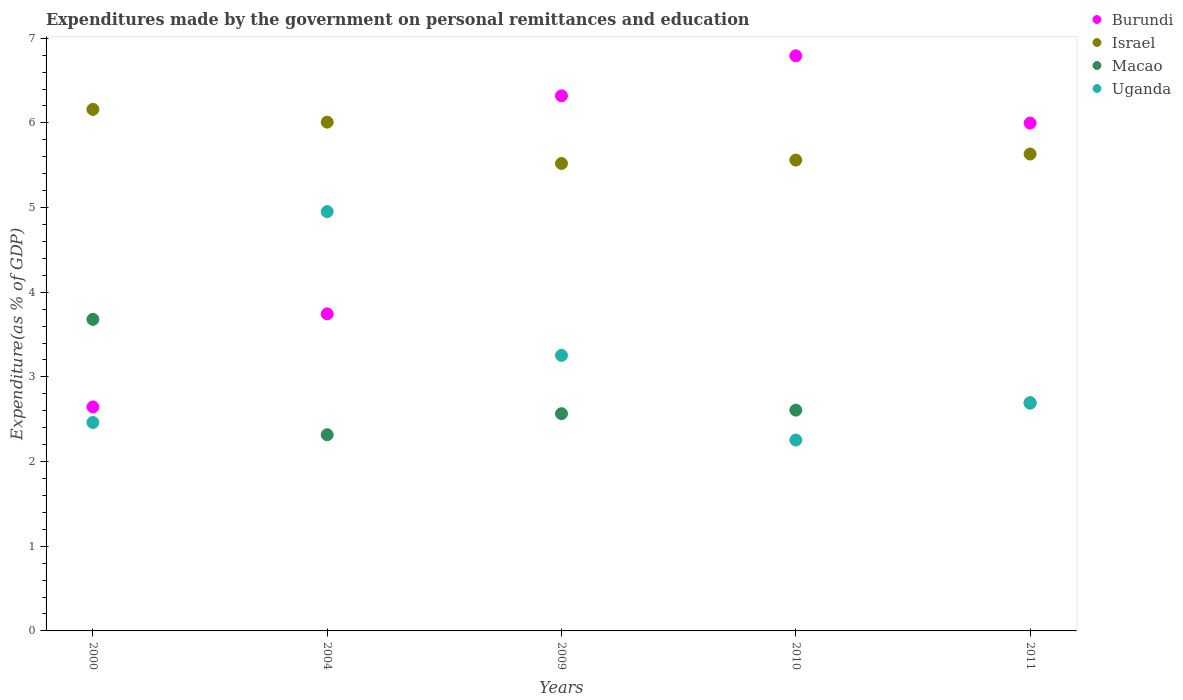How many different coloured dotlines are there?
Provide a succinct answer. 4. What is the expenditures made by the government on personal remittances and education in Macao in 2011?
Ensure brevity in your answer.  2.69. Across all years, what is the maximum expenditures made by the government on personal remittances and education in Israel?
Make the answer very short. 6.16. Across all years, what is the minimum expenditures made by the government on personal remittances and education in Israel?
Provide a succinct answer. 5.52. What is the total expenditures made by the government on personal remittances and education in Israel in the graph?
Give a very brief answer. 28.88. What is the difference between the expenditures made by the government on personal remittances and education in Macao in 2000 and that in 2009?
Give a very brief answer. 1.11. What is the difference between the expenditures made by the government on personal remittances and education in Israel in 2004 and the expenditures made by the government on personal remittances and education in Uganda in 2011?
Give a very brief answer. 3.31. What is the average expenditures made by the government on personal remittances and education in Israel per year?
Give a very brief answer. 5.78. In the year 2000, what is the difference between the expenditures made by the government on personal remittances and education in Macao and expenditures made by the government on personal remittances and education in Israel?
Keep it short and to the point. -2.48. In how many years, is the expenditures made by the government on personal remittances and education in Israel greater than 1.2 %?
Ensure brevity in your answer.  5. What is the ratio of the expenditures made by the government on personal remittances and education in Burundi in 2004 to that in 2010?
Offer a terse response. 0.55. Is the expenditures made by the government on personal remittances and education in Macao in 2004 less than that in 2009?
Make the answer very short. Yes. Is the difference between the expenditures made by the government on personal remittances and education in Macao in 2004 and 2009 greater than the difference between the expenditures made by the government on personal remittances and education in Israel in 2004 and 2009?
Provide a short and direct response. No. What is the difference between the highest and the second highest expenditures made by the government on personal remittances and education in Burundi?
Your answer should be compact. 0.47. What is the difference between the highest and the lowest expenditures made by the government on personal remittances and education in Macao?
Give a very brief answer. 1.36. In how many years, is the expenditures made by the government on personal remittances and education in Uganda greater than the average expenditures made by the government on personal remittances and education in Uganda taken over all years?
Offer a terse response. 2. Is it the case that in every year, the sum of the expenditures made by the government on personal remittances and education in Macao and expenditures made by the government on personal remittances and education in Uganda  is greater than the sum of expenditures made by the government on personal remittances and education in Israel and expenditures made by the government on personal remittances and education in Burundi?
Keep it short and to the point. No. Is the expenditures made by the government on personal remittances and education in Macao strictly greater than the expenditures made by the government on personal remittances and education in Israel over the years?
Offer a very short reply. No. How many dotlines are there?
Your answer should be compact. 4. How many years are there in the graph?
Ensure brevity in your answer.  5. What is the difference between two consecutive major ticks on the Y-axis?
Offer a terse response. 1. Does the graph contain grids?
Offer a terse response. No. Where does the legend appear in the graph?
Offer a very short reply. Top right. How are the legend labels stacked?
Keep it short and to the point. Vertical. What is the title of the graph?
Give a very brief answer. Expenditures made by the government on personal remittances and education. What is the label or title of the X-axis?
Give a very brief answer. Years. What is the label or title of the Y-axis?
Offer a very short reply. Expenditure(as % of GDP). What is the Expenditure(as % of GDP) in Burundi in 2000?
Your answer should be very brief. 2.65. What is the Expenditure(as % of GDP) in Israel in 2000?
Give a very brief answer. 6.16. What is the Expenditure(as % of GDP) of Macao in 2000?
Provide a succinct answer. 3.68. What is the Expenditure(as % of GDP) in Uganda in 2000?
Give a very brief answer. 2.46. What is the Expenditure(as % of GDP) in Burundi in 2004?
Ensure brevity in your answer.  3.74. What is the Expenditure(as % of GDP) of Israel in 2004?
Your answer should be compact. 6.01. What is the Expenditure(as % of GDP) of Macao in 2004?
Make the answer very short. 2.32. What is the Expenditure(as % of GDP) of Uganda in 2004?
Ensure brevity in your answer.  4.95. What is the Expenditure(as % of GDP) in Burundi in 2009?
Provide a short and direct response. 6.32. What is the Expenditure(as % of GDP) in Israel in 2009?
Give a very brief answer. 5.52. What is the Expenditure(as % of GDP) of Macao in 2009?
Provide a short and direct response. 2.57. What is the Expenditure(as % of GDP) in Uganda in 2009?
Ensure brevity in your answer.  3.25. What is the Expenditure(as % of GDP) in Burundi in 2010?
Offer a terse response. 6.79. What is the Expenditure(as % of GDP) of Israel in 2010?
Offer a terse response. 5.56. What is the Expenditure(as % of GDP) in Macao in 2010?
Make the answer very short. 2.61. What is the Expenditure(as % of GDP) of Uganda in 2010?
Offer a very short reply. 2.25. What is the Expenditure(as % of GDP) in Burundi in 2011?
Provide a short and direct response. 6. What is the Expenditure(as % of GDP) in Israel in 2011?
Your response must be concise. 5.63. What is the Expenditure(as % of GDP) in Macao in 2011?
Your response must be concise. 2.69. What is the Expenditure(as % of GDP) of Uganda in 2011?
Keep it short and to the point. 2.7. Across all years, what is the maximum Expenditure(as % of GDP) of Burundi?
Ensure brevity in your answer.  6.79. Across all years, what is the maximum Expenditure(as % of GDP) of Israel?
Your answer should be compact. 6.16. Across all years, what is the maximum Expenditure(as % of GDP) of Macao?
Your response must be concise. 3.68. Across all years, what is the maximum Expenditure(as % of GDP) in Uganda?
Provide a short and direct response. 4.95. Across all years, what is the minimum Expenditure(as % of GDP) of Burundi?
Make the answer very short. 2.65. Across all years, what is the minimum Expenditure(as % of GDP) in Israel?
Offer a very short reply. 5.52. Across all years, what is the minimum Expenditure(as % of GDP) of Macao?
Provide a succinct answer. 2.32. Across all years, what is the minimum Expenditure(as % of GDP) in Uganda?
Offer a terse response. 2.25. What is the total Expenditure(as % of GDP) in Burundi in the graph?
Your answer should be compact. 25.5. What is the total Expenditure(as % of GDP) of Israel in the graph?
Your answer should be very brief. 28.88. What is the total Expenditure(as % of GDP) of Macao in the graph?
Ensure brevity in your answer.  13.86. What is the total Expenditure(as % of GDP) in Uganda in the graph?
Ensure brevity in your answer.  15.62. What is the difference between the Expenditure(as % of GDP) in Burundi in 2000 and that in 2004?
Your answer should be very brief. -1.1. What is the difference between the Expenditure(as % of GDP) of Israel in 2000 and that in 2004?
Offer a terse response. 0.15. What is the difference between the Expenditure(as % of GDP) of Macao in 2000 and that in 2004?
Offer a very short reply. 1.36. What is the difference between the Expenditure(as % of GDP) in Uganda in 2000 and that in 2004?
Make the answer very short. -2.49. What is the difference between the Expenditure(as % of GDP) of Burundi in 2000 and that in 2009?
Provide a short and direct response. -3.67. What is the difference between the Expenditure(as % of GDP) of Israel in 2000 and that in 2009?
Provide a succinct answer. 0.64. What is the difference between the Expenditure(as % of GDP) in Macao in 2000 and that in 2009?
Keep it short and to the point. 1.11. What is the difference between the Expenditure(as % of GDP) of Uganda in 2000 and that in 2009?
Give a very brief answer. -0.79. What is the difference between the Expenditure(as % of GDP) in Burundi in 2000 and that in 2010?
Your response must be concise. -4.15. What is the difference between the Expenditure(as % of GDP) in Israel in 2000 and that in 2010?
Offer a very short reply. 0.6. What is the difference between the Expenditure(as % of GDP) of Macao in 2000 and that in 2010?
Ensure brevity in your answer.  1.07. What is the difference between the Expenditure(as % of GDP) in Uganda in 2000 and that in 2010?
Ensure brevity in your answer.  0.21. What is the difference between the Expenditure(as % of GDP) of Burundi in 2000 and that in 2011?
Offer a terse response. -3.35. What is the difference between the Expenditure(as % of GDP) in Israel in 2000 and that in 2011?
Provide a succinct answer. 0.53. What is the difference between the Expenditure(as % of GDP) in Macao in 2000 and that in 2011?
Make the answer very short. 0.99. What is the difference between the Expenditure(as % of GDP) in Uganda in 2000 and that in 2011?
Give a very brief answer. -0.23. What is the difference between the Expenditure(as % of GDP) of Burundi in 2004 and that in 2009?
Provide a succinct answer. -2.57. What is the difference between the Expenditure(as % of GDP) in Israel in 2004 and that in 2009?
Your response must be concise. 0.49. What is the difference between the Expenditure(as % of GDP) of Macao in 2004 and that in 2009?
Keep it short and to the point. -0.25. What is the difference between the Expenditure(as % of GDP) of Uganda in 2004 and that in 2009?
Your answer should be very brief. 1.7. What is the difference between the Expenditure(as % of GDP) of Burundi in 2004 and that in 2010?
Ensure brevity in your answer.  -3.05. What is the difference between the Expenditure(as % of GDP) in Israel in 2004 and that in 2010?
Give a very brief answer. 0.45. What is the difference between the Expenditure(as % of GDP) in Macao in 2004 and that in 2010?
Your answer should be very brief. -0.29. What is the difference between the Expenditure(as % of GDP) in Uganda in 2004 and that in 2010?
Offer a very short reply. 2.7. What is the difference between the Expenditure(as % of GDP) of Burundi in 2004 and that in 2011?
Your answer should be compact. -2.25. What is the difference between the Expenditure(as % of GDP) in Israel in 2004 and that in 2011?
Make the answer very short. 0.38. What is the difference between the Expenditure(as % of GDP) in Macao in 2004 and that in 2011?
Provide a succinct answer. -0.37. What is the difference between the Expenditure(as % of GDP) of Uganda in 2004 and that in 2011?
Offer a terse response. 2.26. What is the difference between the Expenditure(as % of GDP) in Burundi in 2009 and that in 2010?
Provide a short and direct response. -0.47. What is the difference between the Expenditure(as % of GDP) of Israel in 2009 and that in 2010?
Your response must be concise. -0.04. What is the difference between the Expenditure(as % of GDP) in Macao in 2009 and that in 2010?
Give a very brief answer. -0.04. What is the difference between the Expenditure(as % of GDP) in Burundi in 2009 and that in 2011?
Make the answer very short. 0.32. What is the difference between the Expenditure(as % of GDP) of Israel in 2009 and that in 2011?
Ensure brevity in your answer.  -0.11. What is the difference between the Expenditure(as % of GDP) of Macao in 2009 and that in 2011?
Your response must be concise. -0.12. What is the difference between the Expenditure(as % of GDP) in Uganda in 2009 and that in 2011?
Offer a terse response. 0.56. What is the difference between the Expenditure(as % of GDP) in Burundi in 2010 and that in 2011?
Your response must be concise. 0.8. What is the difference between the Expenditure(as % of GDP) in Israel in 2010 and that in 2011?
Ensure brevity in your answer.  -0.07. What is the difference between the Expenditure(as % of GDP) of Macao in 2010 and that in 2011?
Your answer should be very brief. -0.08. What is the difference between the Expenditure(as % of GDP) of Uganda in 2010 and that in 2011?
Ensure brevity in your answer.  -0.44. What is the difference between the Expenditure(as % of GDP) of Burundi in 2000 and the Expenditure(as % of GDP) of Israel in 2004?
Make the answer very short. -3.36. What is the difference between the Expenditure(as % of GDP) in Burundi in 2000 and the Expenditure(as % of GDP) in Macao in 2004?
Offer a very short reply. 0.33. What is the difference between the Expenditure(as % of GDP) of Burundi in 2000 and the Expenditure(as % of GDP) of Uganda in 2004?
Offer a very short reply. -2.31. What is the difference between the Expenditure(as % of GDP) of Israel in 2000 and the Expenditure(as % of GDP) of Macao in 2004?
Your response must be concise. 3.84. What is the difference between the Expenditure(as % of GDP) in Israel in 2000 and the Expenditure(as % of GDP) in Uganda in 2004?
Provide a short and direct response. 1.21. What is the difference between the Expenditure(as % of GDP) of Macao in 2000 and the Expenditure(as % of GDP) of Uganda in 2004?
Give a very brief answer. -1.27. What is the difference between the Expenditure(as % of GDP) in Burundi in 2000 and the Expenditure(as % of GDP) in Israel in 2009?
Offer a very short reply. -2.88. What is the difference between the Expenditure(as % of GDP) in Burundi in 2000 and the Expenditure(as % of GDP) in Macao in 2009?
Offer a very short reply. 0.08. What is the difference between the Expenditure(as % of GDP) of Burundi in 2000 and the Expenditure(as % of GDP) of Uganda in 2009?
Your answer should be very brief. -0.61. What is the difference between the Expenditure(as % of GDP) in Israel in 2000 and the Expenditure(as % of GDP) in Macao in 2009?
Ensure brevity in your answer.  3.59. What is the difference between the Expenditure(as % of GDP) of Israel in 2000 and the Expenditure(as % of GDP) of Uganda in 2009?
Your answer should be compact. 2.91. What is the difference between the Expenditure(as % of GDP) of Macao in 2000 and the Expenditure(as % of GDP) of Uganda in 2009?
Your response must be concise. 0.43. What is the difference between the Expenditure(as % of GDP) in Burundi in 2000 and the Expenditure(as % of GDP) in Israel in 2010?
Provide a succinct answer. -2.92. What is the difference between the Expenditure(as % of GDP) in Burundi in 2000 and the Expenditure(as % of GDP) in Macao in 2010?
Ensure brevity in your answer.  0.04. What is the difference between the Expenditure(as % of GDP) in Burundi in 2000 and the Expenditure(as % of GDP) in Uganda in 2010?
Provide a succinct answer. 0.39. What is the difference between the Expenditure(as % of GDP) of Israel in 2000 and the Expenditure(as % of GDP) of Macao in 2010?
Give a very brief answer. 3.55. What is the difference between the Expenditure(as % of GDP) of Israel in 2000 and the Expenditure(as % of GDP) of Uganda in 2010?
Provide a short and direct response. 3.91. What is the difference between the Expenditure(as % of GDP) in Macao in 2000 and the Expenditure(as % of GDP) in Uganda in 2010?
Give a very brief answer. 1.43. What is the difference between the Expenditure(as % of GDP) in Burundi in 2000 and the Expenditure(as % of GDP) in Israel in 2011?
Your response must be concise. -2.99. What is the difference between the Expenditure(as % of GDP) of Burundi in 2000 and the Expenditure(as % of GDP) of Macao in 2011?
Provide a succinct answer. -0.05. What is the difference between the Expenditure(as % of GDP) of Burundi in 2000 and the Expenditure(as % of GDP) of Uganda in 2011?
Your response must be concise. -0.05. What is the difference between the Expenditure(as % of GDP) of Israel in 2000 and the Expenditure(as % of GDP) of Macao in 2011?
Make the answer very short. 3.47. What is the difference between the Expenditure(as % of GDP) of Israel in 2000 and the Expenditure(as % of GDP) of Uganda in 2011?
Make the answer very short. 3.46. What is the difference between the Expenditure(as % of GDP) in Macao in 2000 and the Expenditure(as % of GDP) in Uganda in 2011?
Your answer should be compact. 0.98. What is the difference between the Expenditure(as % of GDP) in Burundi in 2004 and the Expenditure(as % of GDP) in Israel in 2009?
Your answer should be very brief. -1.78. What is the difference between the Expenditure(as % of GDP) in Burundi in 2004 and the Expenditure(as % of GDP) in Macao in 2009?
Your answer should be very brief. 1.18. What is the difference between the Expenditure(as % of GDP) of Burundi in 2004 and the Expenditure(as % of GDP) of Uganda in 2009?
Give a very brief answer. 0.49. What is the difference between the Expenditure(as % of GDP) of Israel in 2004 and the Expenditure(as % of GDP) of Macao in 2009?
Your answer should be very brief. 3.44. What is the difference between the Expenditure(as % of GDP) in Israel in 2004 and the Expenditure(as % of GDP) in Uganda in 2009?
Keep it short and to the point. 2.75. What is the difference between the Expenditure(as % of GDP) of Macao in 2004 and the Expenditure(as % of GDP) of Uganda in 2009?
Your response must be concise. -0.94. What is the difference between the Expenditure(as % of GDP) in Burundi in 2004 and the Expenditure(as % of GDP) in Israel in 2010?
Ensure brevity in your answer.  -1.82. What is the difference between the Expenditure(as % of GDP) in Burundi in 2004 and the Expenditure(as % of GDP) in Macao in 2010?
Provide a short and direct response. 1.14. What is the difference between the Expenditure(as % of GDP) of Burundi in 2004 and the Expenditure(as % of GDP) of Uganda in 2010?
Provide a succinct answer. 1.49. What is the difference between the Expenditure(as % of GDP) in Israel in 2004 and the Expenditure(as % of GDP) in Macao in 2010?
Ensure brevity in your answer.  3.4. What is the difference between the Expenditure(as % of GDP) in Israel in 2004 and the Expenditure(as % of GDP) in Uganda in 2010?
Your response must be concise. 3.75. What is the difference between the Expenditure(as % of GDP) in Macao in 2004 and the Expenditure(as % of GDP) in Uganda in 2010?
Make the answer very short. 0.06. What is the difference between the Expenditure(as % of GDP) of Burundi in 2004 and the Expenditure(as % of GDP) of Israel in 2011?
Provide a short and direct response. -1.89. What is the difference between the Expenditure(as % of GDP) in Burundi in 2004 and the Expenditure(as % of GDP) in Macao in 2011?
Provide a succinct answer. 1.05. What is the difference between the Expenditure(as % of GDP) in Burundi in 2004 and the Expenditure(as % of GDP) in Uganda in 2011?
Make the answer very short. 1.05. What is the difference between the Expenditure(as % of GDP) in Israel in 2004 and the Expenditure(as % of GDP) in Macao in 2011?
Your answer should be very brief. 3.32. What is the difference between the Expenditure(as % of GDP) in Israel in 2004 and the Expenditure(as % of GDP) in Uganda in 2011?
Make the answer very short. 3.31. What is the difference between the Expenditure(as % of GDP) of Macao in 2004 and the Expenditure(as % of GDP) of Uganda in 2011?
Your answer should be very brief. -0.38. What is the difference between the Expenditure(as % of GDP) of Burundi in 2009 and the Expenditure(as % of GDP) of Israel in 2010?
Your answer should be compact. 0.76. What is the difference between the Expenditure(as % of GDP) in Burundi in 2009 and the Expenditure(as % of GDP) in Macao in 2010?
Make the answer very short. 3.71. What is the difference between the Expenditure(as % of GDP) in Burundi in 2009 and the Expenditure(as % of GDP) in Uganda in 2010?
Make the answer very short. 4.07. What is the difference between the Expenditure(as % of GDP) in Israel in 2009 and the Expenditure(as % of GDP) in Macao in 2010?
Provide a succinct answer. 2.91. What is the difference between the Expenditure(as % of GDP) in Israel in 2009 and the Expenditure(as % of GDP) in Uganda in 2010?
Keep it short and to the point. 3.27. What is the difference between the Expenditure(as % of GDP) in Macao in 2009 and the Expenditure(as % of GDP) in Uganda in 2010?
Ensure brevity in your answer.  0.31. What is the difference between the Expenditure(as % of GDP) of Burundi in 2009 and the Expenditure(as % of GDP) of Israel in 2011?
Your response must be concise. 0.69. What is the difference between the Expenditure(as % of GDP) in Burundi in 2009 and the Expenditure(as % of GDP) in Macao in 2011?
Offer a terse response. 3.63. What is the difference between the Expenditure(as % of GDP) in Burundi in 2009 and the Expenditure(as % of GDP) in Uganda in 2011?
Offer a terse response. 3.62. What is the difference between the Expenditure(as % of GDP) in Israel in 2009 and the Expenditure(as % of GDP) in Macao in 2011?
Your response must be concise. 2.83. What is the difference between the Expenditure(as % of GDP) of Israel in 2009 and the Expenditure(as % of GDP) of Uganda in 2011?
Your response must be concise. 2.83. What is the difference between the Expenditure(as % of GDP) in Macao in 2009 and the Expenditure(as % of GDP) in Uganda in 2011?
Provide a succinct answer. -0.13. What is the difference between the Expenditure(as % of GDP) in Burundi in 2010 and the Expenditure(as % of GDP) in Israel in 2011?
Your response must be concise. 1.16. What is the difference between the Expenditure(as % of GDP) in Burundi in 2010 and the Expenditure(as % of GDP) in Macao in 2011?
Your response must be concise. 4.1. What is the difference between the Expenditure(as % of GDP) in Burundi in 2010 and the Expenditure(as % of GDP) in Uganda in 2011?
Your answer should be compact. 4.1. What is the difference between the Expenditure(as % of GDP) of Israel in 2010 and the Expenditure(as % of GDP) of Macao in 2011?
Your response must be concise. 2.87. What is the difference between the Expenditure(as % of GDP) of Israel in 2010 and the Expenditure(as % of GDP) of Uganda in 2011?
Offer a terse response. 2.87. What is the difference between the Expenditure(as % of GDP) of Macao in 2010 and the Expenditure(as % of GDP) of Uganda in 2011?
Your answer should be compact. -0.09. What is the average Expenditure(as % of GDP) of Burundi per year?
Offer a terse response. 5.1. What is the average Expenditure(as % of GDP) of Israel per year?
Offer a very short reply. 5.78. What is the average Expenditure(as % of GDP) of Macao per year?
Offer a terse response. 2.77. What is the average Expenditure(as % of GDP) of Uganda per year?
Your answer should be very brief. 3.12. In the year 2000, what is the difference between the Expenditure(as % of GDP) of Burundi and Expenditure(as % of GDP) of Israel?
Your response must be concise. -3.51. In the year 2000, what is the difference between the Expenditure(as % of GDP) in Burundi and Expenditure(as % of GDP) in Macao?
Offer a very short reply. -1.03. In the year 2000, what is the difference between the Expenditure(as % of GDP) in Burundi and Expenditure(as % of GDP) in Uganda?
Keep it short and to the point. 0.18. In the year 2000, what is the difference between the Expenditure(as % of GDP) of Israel and Expenditure(as % of GDP) of Macao?
Provide a short and direct response. 2.48. In the year 2000, what is the difference between the Expenditure(as % of GDP) of Israel and Expenditure(as % of GDP) of Uganda?
Offer a terse response. 3.7. In the year 2000, what is the difference between the Expenditure(as % of GDP) of Macao and Expenditure(as % of GDP) of Uganda?
Make the answer very short. 1.22. In the year 2004, what is the difference between the Expenditure(as % of GDP) in Burundi and Expenditure(as % of GDP) in Israel?
Your answer should be very brief. -2.26. In the year 2004, what is the difference between the Expenditure(as % of GDP) in Burundi and Expenditure(as % of GDP) in Macao?
Your answer should be compact. 1.43. In the year 2004, what is the difference between the Expenditure(as % of GDP) in Burundi and Expenditure(as % of GDP) in Uganda?
Provide a succinct answer. -1.21. In the year 2004, what is the difference between the Expenditure(as % of GDP) of Israel and Expenditure(as % of GDP) of Macao?
Ensure brevity in your answer.  3.69. In the year 2004, what is the difference between the Expenditure(as % of GDP) in Israel and Expenditure(as % of GDP) in Uganda?
Offer a very short reply. 1.06. In the year 2004, what is the difference between the Expenditure(as % of GDP) in Macao and Expenditure(as % of GDP) in Uganda?
Keep it short and to the point. -2.64. In the year 2009, what is the difference between the Expenditure(as % of GDP) of Burundi and Expenditure(as % of GDP) of Israel?
Keep it short and to the point. 0.8. In the year 2009, what is the difference between the Expenditure(as % of GDP) in Burundi and Expenditure(as % of GDP) in Macao?
Provide a succinct answer. 3.75. In the year 2009, what is the difference between the Expenditure(as % of GDP) in Burundi and Expenditure(as % of GDP) in Uganda?
Your response must be concise. 3.07. In the year 2009, what is the difference between the Expenditure(as % of GDP) in Israel and Expenditure(as % of GDP) in Macao?
Offer a terse response. 2.96. In the year 2009, what is the difference between the Expenditure(as % of GDP) of Israel and Expenditure(as % of GDP) of Uganda?
Keep it short and to the point. 2.27. In the year 2009, what is the difference between the Expenditure(as % of GDP) in Macao and Expenditure(as % of GDP) in Uganda?
Ensure brevity in your answer.  -0.69. In the year 2010, what is the difference between the Expenditure(as % of GDP) of Burundi and Expenditure(as % of GDP) of Israel?
Offer a terse response. 1.23. In the year 2010, what is the difference between the Expenditure(as % of GDP) of Burundi and Expenditure(as % of GDP) of Macao?
Ensure brevity in your answer.  4.19. In the year 2010, what is the difference between the Expenditure(as % of GDP) of Burundi and Expenditure(as % of GDP) of Uganda?
Give a very brief answer. 4.54. In the year 2010, what is the difference between the Expenditure(as % of GDP) in Israel and Expenditure(as % of GDP) in Macao?
Provide a short and direct response. 2.95. In the year 2010, what is the difference between the Expenditure(as % of GDP) of Israel and Expenditure(as % of GDP) of Uganda?
Keep it short and to the point. 3.31. In the year 2010, what is the difference between the Expenditure(as % of GDP) of Macao and Expenditure(as % of GDP) of Uganda?
Offer a terse response. 0.35. In the year 2011, what is the difference between the Expenditure(as % of GDP) of Burundi and Expenditure(as % of GDP) of Israel?
Provide a short and direct response. 0.36. In the year 2011, what is the difference between the Expenditure(as % of GDP) of Burundi and Expenditure(as % of GDP) of Macao?
Your answer should be very brief. 3.31. In the year 2011, what is the difference between the Expenditure(as % of GDP) in Burundi and Expenditure(as % of GDP) in Uganda?
Ensure brevity in your answer.  3.3. In the year 2011, what is the difference between the Expenditure(as % of GDP) in Israel and Expenditure(as % of GDP) in Macao?
Make the answer very short. 2.94. In the year 2011, what is the difference between the Expenditure(as % of GDP) in Israel and Expenditure(as % of GDP) in Uganda?
Your response must be concise. 2.94. In the year 2011, what is the difference between the Expenditure(as % of GDP) of Macao and Expenditure(as % of GDP) of Uganda?
Give a very brief answer. -0.01. What is the ratio of the Expenditure(as % of GDP) of Burundi in 2000 to that in 2004?
Provide a succinct answer. 0.71. What is the ratio of the Expenditure(as % of GDP) in Israel in 2000 to that in 2004?
Provide a short and direct response. 1.03. What is the ratio of the Expenditure(as % of GDP) in Macao in 2000 to that in 2004?
Provide a succinct answer. 1.59. What is the ratio of the Expenditure(as % of GDP) in Uganda in 2000 to that in 2004?
Provide a succinct answer. 0.5. What is the ratio of the Expenditure(as % of GDP) of Burundi in 2000 to that in 2009?
Ensure brevity in your answer.  0.42. What is the ratio of the Expenditure(as % of GDP) of Israel in 2000 to that in 2009?
Your response must be concise. 1.12. What is the ratio of the Expenditure(as % of GDP) of Macao in 2000 to that in 2009?
Keep it short and to the point. 1.43. What is the ratio of the Expenditure(as % of GDP) in Uganda in 2000 to that in 2009?
Offer a very short reply. 0.76. What is the ratio of the Expenditure(as % of GDP) in Burundi in 2000 to that in 2010?
Make the answer very short. 0.39. What is the ratio of the Expenditure(as % of GDP) of Israel in 2000 to that in 2010?
Offer a very short reply. 1.11. What is the ratio of the Expenditure(as % of GDP) of Macao in 2000 to that in 2010?
Provide a succinct answer. 1.41. What is the ratio of the Expenditure(as % of GDP) in Uganda in 2000 to that in 2010?
Give a very brief answer. 1.09. What is the ratio of the Expenditure(as % of GDP) in Burundi in 2000 to that in 2011?
Give a very brief answer. 0.44. What is the ratio of the Expenditure(as % of GDP) of Israel in 2000 to that in 2011?
Offer a terse response. 1.09. What is the ratio of the Expenditure(as % of GDP) in Macao in 2000 to that in 2011?
Your response must be concise. 1.37. What is the ratio of the Expenditure(as % of GDP) in Uganda in 2000 to that in 2011?
Ensure brevity in your answer.  0.91. What is the ratio of the Expenditure(as % of GDP) of Burundi in 2004 to that in 2009?
Your response must be concise. 0.59. What is the ratio of the Expenditure(as % of GDP) in Israel in 2004 to that in 2009?
Offer a terse response. 1.09. What is the ratio of the Expenditure(as % of GDP) in Macao in 2004 to that in 2009?
Your answer should be very brief. 0.9. What is the ratio of the Expenditure(as % of GDP) in Uganda in 2004 to that in 2009?
Keep it short and to the point. 1.52. What is the ratio of the Expenditure(as % of GDP) of Burundi in 2004 to that in 2010?
Keep it short and to the point. 0.55. What is the ratio of the Expenditure(as % of GDP) in Israel in 2004 to that in 2010?
Make the answer very short. 1.08. What is the ratio of the Expenditure(as % of GDP) of Macao in 2004 to that in 2010?
Make the answer very short. 0.89. What is the ratio of the Expenditure(as % of GDP) of Uganda in 2004 to that in 2010?
Give a very brief answer. 2.2. What is the ratio of the Expenditure(as % of GDP) of Burundi in 2004 to that in 2011?
Make the answer very short. 0.62. What is the ratio of the Expenditure(as % of GDP) of Israel in 2004 to that in 2011?
Provide a short and direct response. 1.07. What is the ratio of the Expenditure(as % of GDP) in Macao in 2004 to that in 2011?
Your answer should be very brief. 0.86. What is the ratio of the Expenditure(as % of GDP) in Uganda in 2004 to that in 2011?
Give a very brief answer. 1.84. What is the ratio of the Expenditure(as % of GDP) of Burundi in 2009 to that in 2010?
Give a very brief answer. 0.93. What is the ratio of the Expenditure(as % of GDP) in Macao in 2009 to that in 2010?
Ensure brevity in your answer.  0.98. What is the ratio of the Expenditure(as % of GDP) in Uganda in 2009 to that in 2010?
Make the answer very short. 1.44. What is the ratio of the Expenditure(as % of GDP) of Burundi in 2009 to that in 2011?
Offer a terse response. 1.05. What is the ratio of the Expenditure(as % of GDP) of Israel in 2009 to that in 2011?
Provide a short and direct response. 0.98. What is the ratio of the Expenditure(as % of GDP) in Macao in 2009 to that in 2011?
Provide a succinct answer. 0.95. What is the ratio of the Expenditure(as % of GDP) of Uganda in 2009 to that in 2011?
Your answer should be compact. 1.21. What is the ratio of the Expenditure(as % of GDP) of Burundi in 2010 to that in 2011?
Your response must be concise. 1.13. What is the ratio of the Expenditure(as % of GDP) in Israel in 2010 to that in 2011?
Provide a short and direct response. 0.99. What is the ratio of the Expenditure(as % of GDP) of Macao in 2010 to that in 2011?
Provide a short and direct response. 0.97. What is the ratio of the Expenditure(as % of GDP) in Uganda in 2010 to that in 2011?
Your answer should be compact. 0.84. What is the difference between the highest and the second highest Expenditure(as % of GDP) of Burundi?
Provide a short and direct response. 0.47. What is the difference between the highest and the second highest Expenditure(as % of GDP) of Israel?
Keep it short and to the point. 0.15. What is the difference between the highest and the second highest Expenditure(as % of GDP) of Macao?
Provide a succinct answer. 0.99. What is the difference between the highest and the second highest Expenditure(as % of GDP) of Uganda?
Provide a short and direct response. 1.7. What is the difference between the highest and the lowest Expenditure(as % of GDP) in Burundi?
Your response must be concise. 4.15. What is the difference between the highest and the lowest Expenditure(as % of GDP) in Israel?
Keep it short and to the point. 0.64. What is the difference between the highest and the lowest Expenditure(as % of GDP) of Macao?
Offer a very short reply. 1.36. What is the difference between the highest and the lowest Expenditure(as % of GDP) of Uganda?
Give a very brief answer. 2.7. 